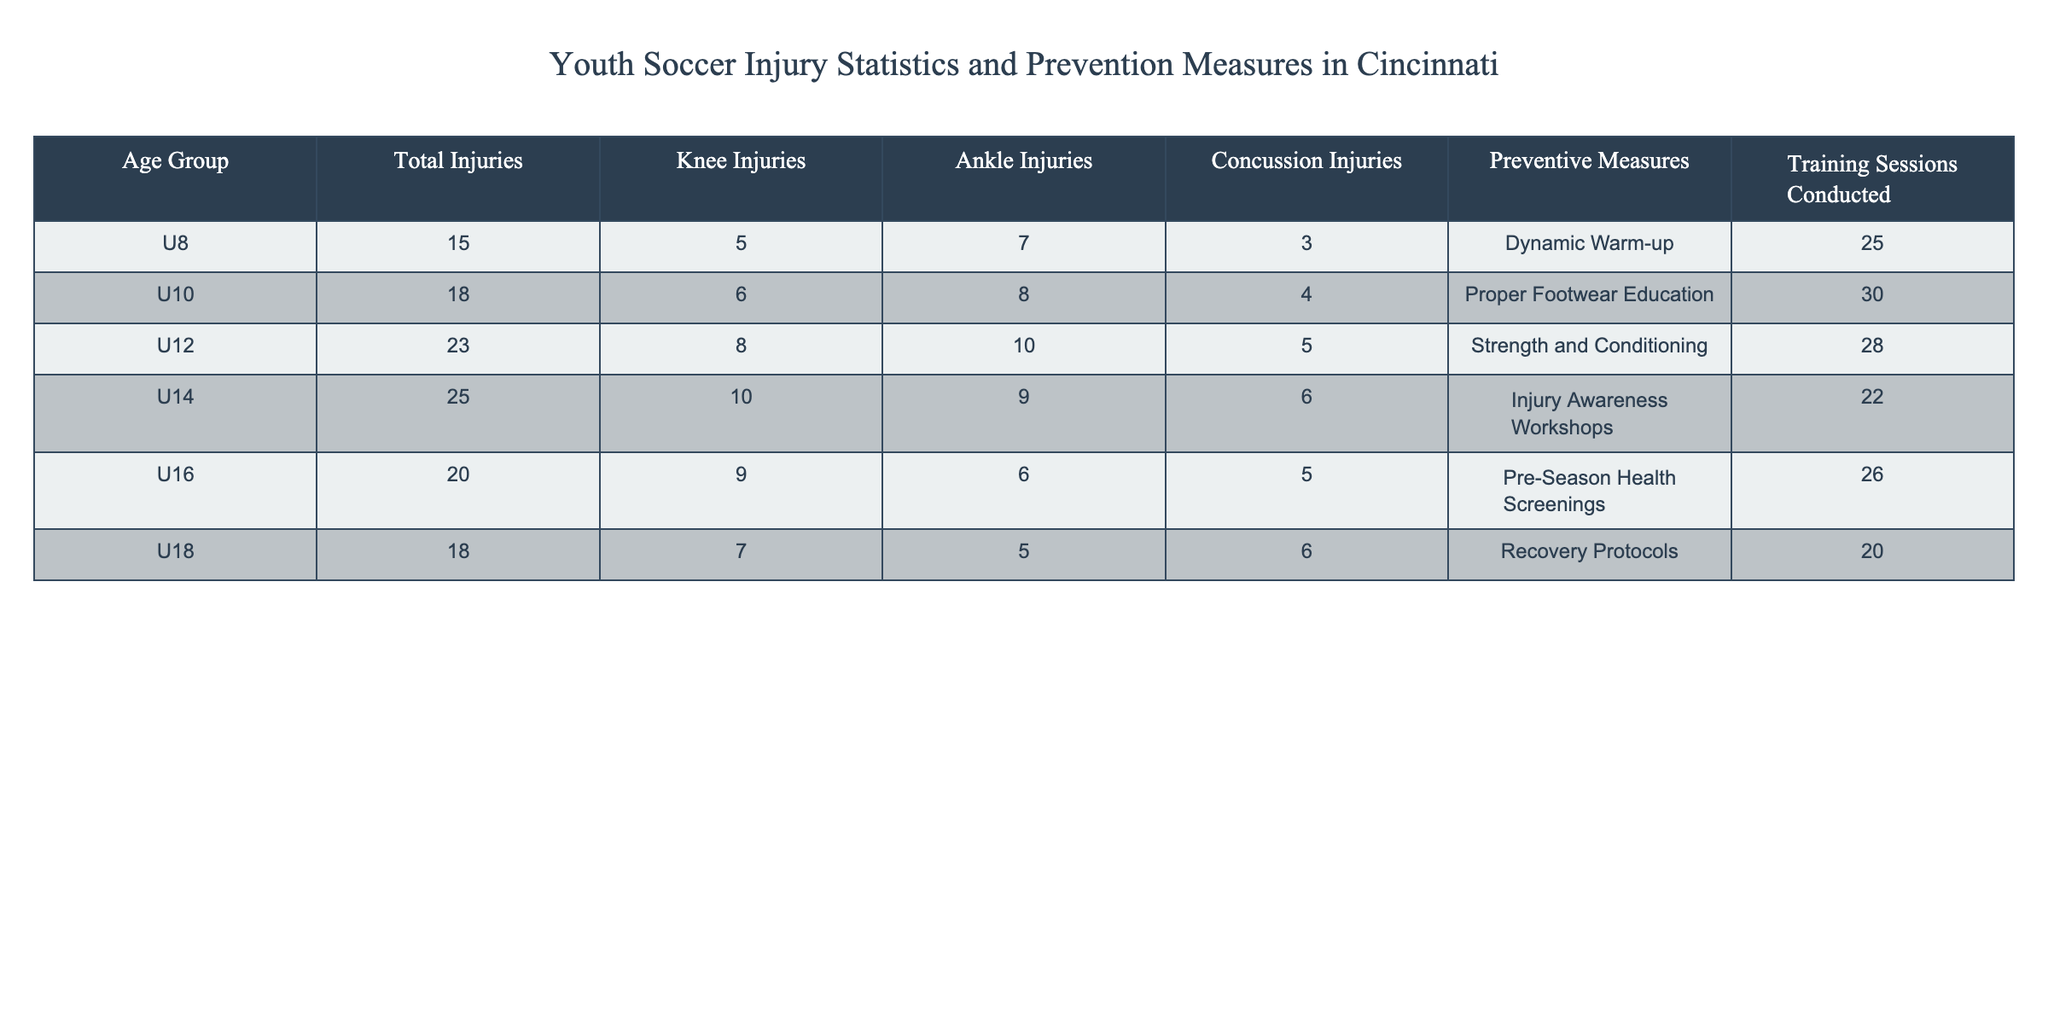What is the total number of injuries for the U12 age group? Referring to the table under the 'Total Injuries' column for the U12 age group, it shows a total of 23 injuries.
Answer: 23 Which age group has the highest number of knee injuries? Looking at the 'Knee Injuries' column, the U14 age group has the highest value with 10 knee injuries.
Answer: U14 What preventive measure is listed for the U16 age group? The 'Preventive Measures' column for the U16 age group indicates that "Pre-Season Health Screenings" are the recommended preventive measure.
Answer: Pre-Season Health Screenings Is there an age group with more than 20 total injuries? Reviewing the 'Total Injuries' column, both the U12 (23) and U14 (25) age groups have more than 20 total injuries, so the answer is yes.
Answer: Yes What is the average number of ankle injuries across all age groups? To find the average, sum the ankle injuries: 7 + 8 + 10 + 9 + 6 + 5 = 45, then divide by 6 (the number of age groups), resulting in an average of 45/6 = 7.5.
Answer: 7.5 How many more concussions were reported in the U14 age group compared to the U18 age group? The U14 age group has 6 concussions and the U18 has 6 as well, so the difference is 6 - 6 = 0.
Answer: 0 Which preventive measure corresponds with the U10 age group? The 'Preventive Measures' column for the U10 age group lists "Proper Footwear Education."
Answer: Proper Footwear Education Are recovery protocols implemented for U8 players? Checking the 'Preventive Measures' column for the U8 players, it shows "Dynamic Warm-up," indicating recovery protocols are not listed, so the answer is no.
Answer: No How many total injuries are reported for the U16 age group? The table under 'Total Injuries' for the U16 age group shows there are 20 reported injuries.
Answer: 20 Which age group has the least number of total injuries? By examining the 'Total Injuries' column, the U8 age group has the least total injuries with 15.
Answer: U8 